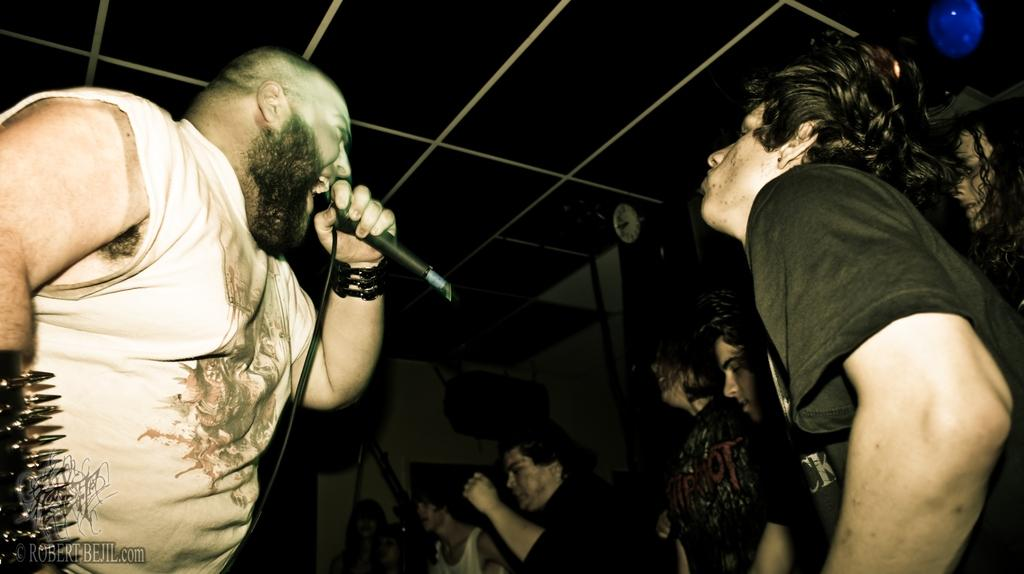What is the person in the image doing? The person is standing in the image and holding a mic in his hands. Can you describe the people in the background of the image? There are people standing in the background of the image. What might the person with the mic be doing? The person with the mic might be giving a speech or performing. What type of power source is used to operate the scale in the image? There is no scale present in the image, so it is not possible to determine the type of power source used. 